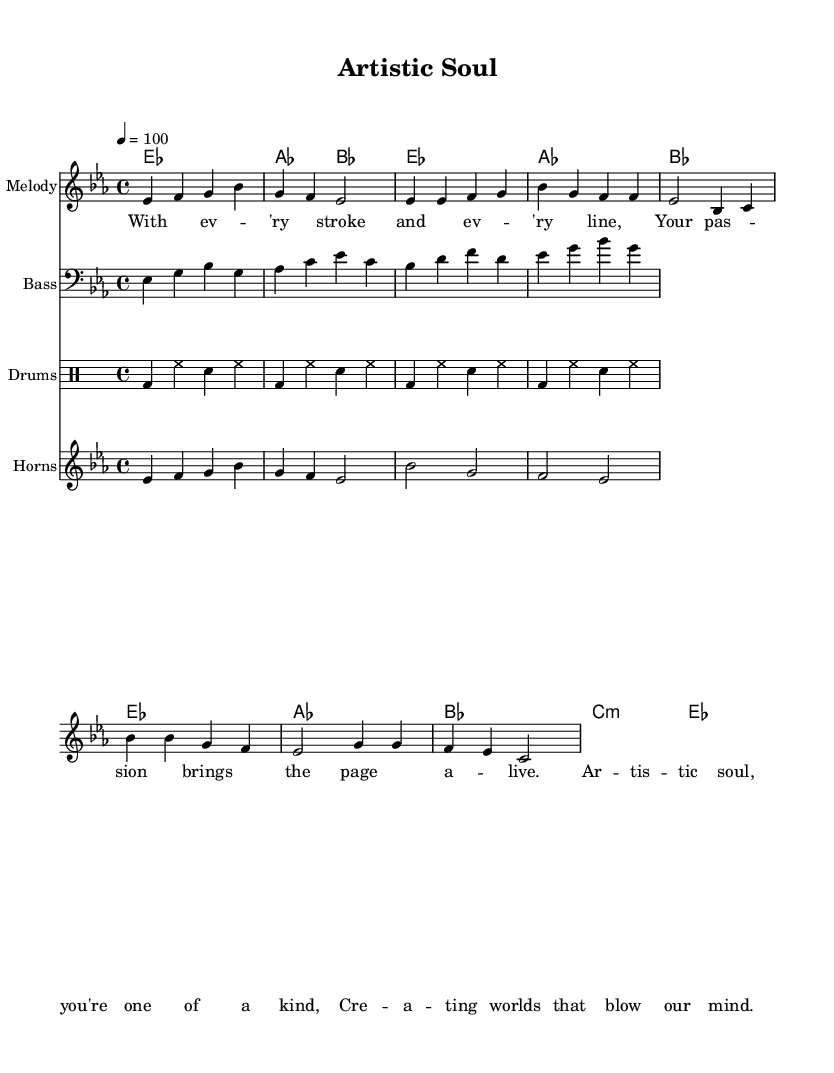What is the key signature of this music? The key signature is indicated at the beginning of the staff with two flats, which corresponds to E flat major.
Answer: E flat major What is the time signature of this piece? The time signature is indicated at the beginning of the score, which specifies that there are four beats in each measure.
Answer: 4/4 What is the tempo marking of this music? The tempo is indicated in beats per minute, showing a figure of 100, which suggests a moderately fast pace for the piece.
Answer: 100 How many measures are in the verse section? By counting the measures in the verse lines provided, we see there are eight measures before transitioning to the chorus.
Answer: 8 What is the main theme of the lyrics? The lyrics repeatedly emphasize the uniqueness and impact of the artist's creativity, stating that artistic soul brings life to the page.
Answer: Artistic expression Which instruments are included in this score? The score features several specific instruments listed at the beginning: Melody, Bass, Drums, and Horns.
Answer: Melody, Bass, Drums, Horns Which chord is used in the chorus section? In the chorus, the chords presented include B flat major and C minor, indicating a shift in harmonic texture.
Answer: B flat major, C minor 